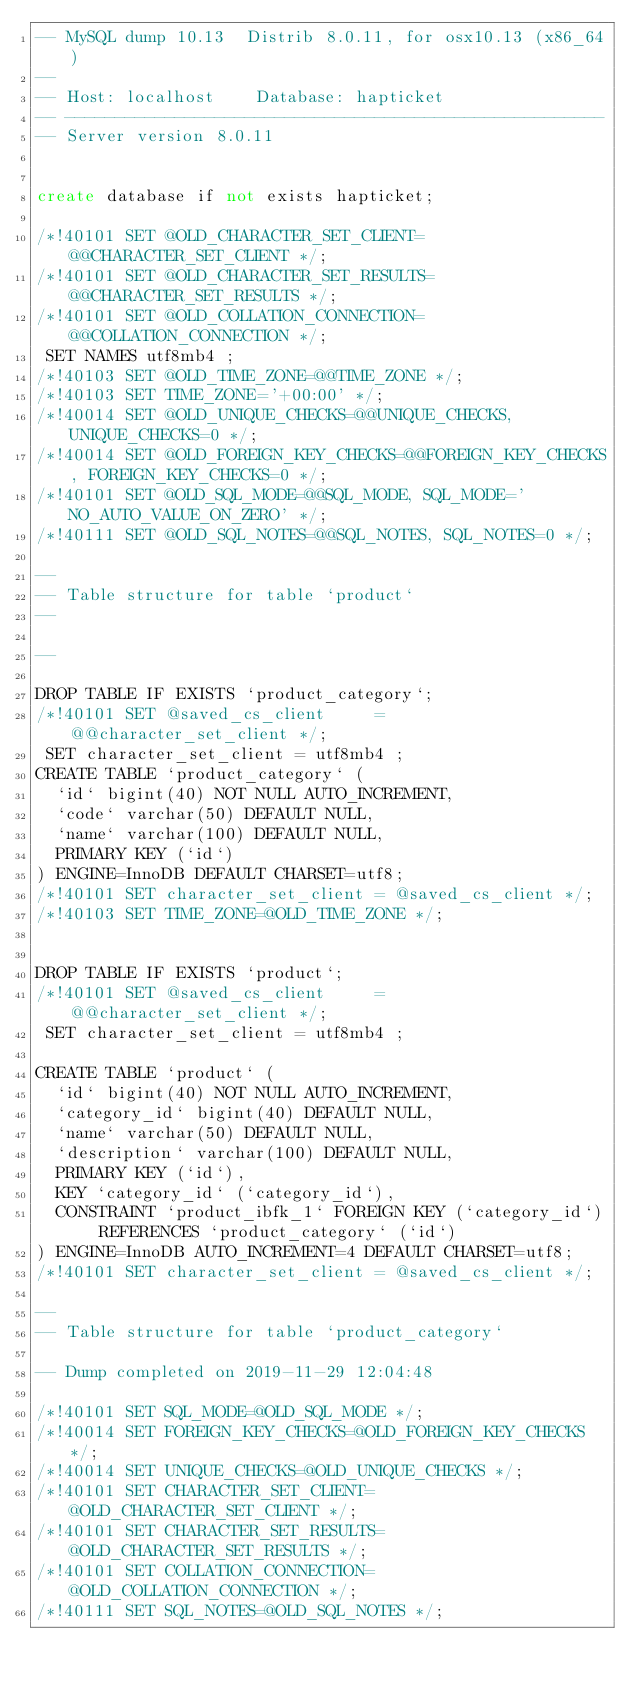Convert code to text. <code><loc_0><loc_0><loc_500><loc_500><_SQL_>-- MySQL dump 10.13  Distrib 8.0.11, for osx10.13 (x86_64)
--
-- Host: localhost    Database: hapticket
-- ------------------------------------------------------
-- Server version	8.0.11


create database if not exists hapticket;

/*!40101 SET @OLD_CHARACTER_SET_CLIENT=@@CHARACTER_SET_CLIENT */;
/*!40101 SET @OLD_CHARACTER_SET_RESULTS=@@CHARACTER_SET_RESULTS */;
/*!40101 SET @OLD_COLLATION_CONNECTION=@@COLLATION_CONNECTION */;
 SET NAMES utf8mb4 ;
/*!40103 SET @OLD_TIME_ZONE=@@TIME_ZONE */;
/*!40103 SET TIME_ZONE='+00:00' */;
/*!40014 SET @OLD_UNIQUE_CHECKS=@@UNIQUE_CHECKS, UNIQUE_CHECKS=0 */;
/*!40014 SET @OLD_FOREIGN_KEY_CHECKS=@@FOREIGN_KEY_CHECKS, FOREIGN_KEY_CHECKS=0 */;
/*!40101 SET @OLD_SQL_MODE=@@SQL_MODE, SQL_MODE='NO_AUTO_VALUE_ON_ZERO' */;
/*!40111 SET @OLD_SQL_NOTES=@@SQL_NOTES, SQL_NOTES=0 */;

--
-- Table structure for table `product`
--

--

DROP TABLE IF EXISTS `product_category`;
/*!40101 SET @saved_cs_client     = @@character_set_client */;
 SET character_set_client = utf8mb4 ;
CREATE TABLE `product_category` (
  `id` bigint(40) NOT NULL AUTO_INCREMENT,
  `code` varchar(50) DEFAULT NULL,
  `name` varchar(100) DEFAULT NULL,
  PRIMARY KEY (`id`)
) ENGINE=InnoDB DEFAULT CHARSET=utf8;
/*!40101 SET character_set_client = @saved_cs_client */;
/*!40103 SET TIME_ZONE=@OLD_TIME_ZONE */;


DROP TABLE IF EXISTS `product`;
/*!40101 SET @saved_cs_client     = @@character_set_client */;
 SET character_set_client = utf8mb4 ;
 
CREATE TABLE `product` (
  `id` bigint(40) NOT NULL AUTO_INCREMENT,
  `category_id` bigint(40) DEFAULT NULL,
  `name` varchar(50) DEFAULT NULL,
  `description` varchar(100) DEFAULT NULL,
  PRIMARY KEY (`id`),
  KEY `category_id` (`category_id`),
  CONSTRAINT `product_ibfk_1` FOREIGN KEY (`category_id`) REFERENCES `product_category` (`id`)
) ENGINE=InnoDB AUTO_INCREMENT=4 DEFAULT CHARSET=utf8;
/*!40101 SET character_set_client = @saved_cs_client */;

--
-- Table structure for table `product_category`

-- Dump completed on 2019-11-29 12:04:48

/*!40101 SET SQL_MODE=@OLD_SQL_MODE */;
/*!40014 SET FOREIGN_KEY_CHECKS=@OLD_FOREIGN_KEY_CHECKS */;
/*!40014 SET UNIQUE_CHECKS=@OLD_UNIQUE_CHECKS */;
/*!40101 SET CHARACTER_SET_CLIENT=@OLD_CHARACTER_SET_CLIENT */;
/*!40101 SET CHARACTER_SET_RESULTS=@OLD_CHARACTER_SET_RESULTS */;
/*!40101 SET COLLATION_CONNECTION=@OLD_COLLATION_CONNECTION */;
/*!40111 SET SQL_NOTES=@OLD_SQL_NOTES */;

</code> 